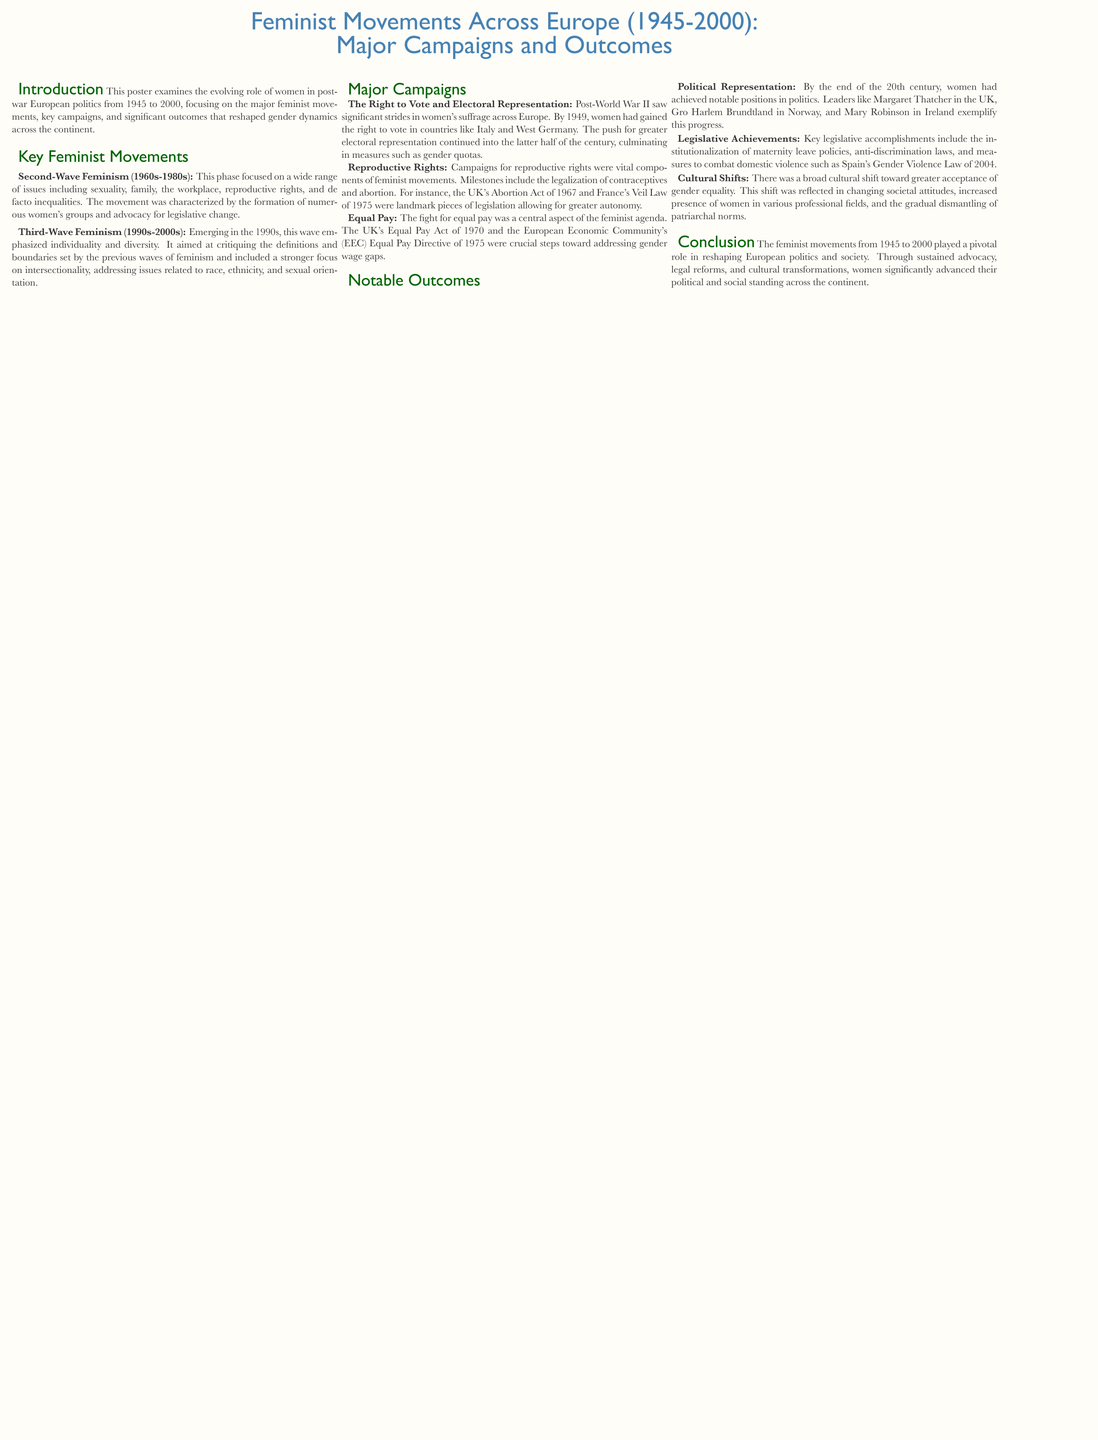What are the years covered in the poster? The years covered in the poster are clearly stated in the title as 1945 to 2000.
Answer: 1945 to 2000 What political act was landmark legislation in the UK for reproductive rights? The specific act mentioned regarding reproductive rights in the UK is the Abortion Act of 1967.
Answer: Abortion Act of 1967 Which feminist wave emphasized individuality and diversity? The wave that emphasized individuality and diversity is referenced in the section on Third-Wave Feminism.
Answer: Third-Wave Feminism What was a significant outcome regarding women's political representation by the end of the 20th century? The poster notes that by the end of the 20th century, women achieved notable positions in politics, naming specific leaders while summarizing the progress made.
Answer: Notable positions in politics What major campaign is highlighted in the document related to voting rights? The major campaign related to voting rights is described in the section on The Right to Vote and Electoral Representation.
Answer: The Right to Vote and Electoral Representation Which country implemented the Gender Violence Law in 2004? The Gender Violence Law mentioned as a legislative achievement is from Spain, as noted in the outcomes section.
Answer: Spain What common theme is present in the campaigns for reproductive rights and equal pay? The common theme in these campaigns is centered on advocating for women's rights and autonomy in social and economic matters.
Answer: Women's rights and autonomy What was a cultural shift mentioned in the document regarding gender equality? The poster highlights a broad cultural shift toward greater acceptance of gender equality as an important societal change.
Answer: Acceptance of gender equality Which feminist movement focused on issues including sexuality and reproductive rights? The movement that focused on sexuality and reproductive rights is identified as Second-Wave Feminism in the document.
Answer: Second-Wave Feminism 